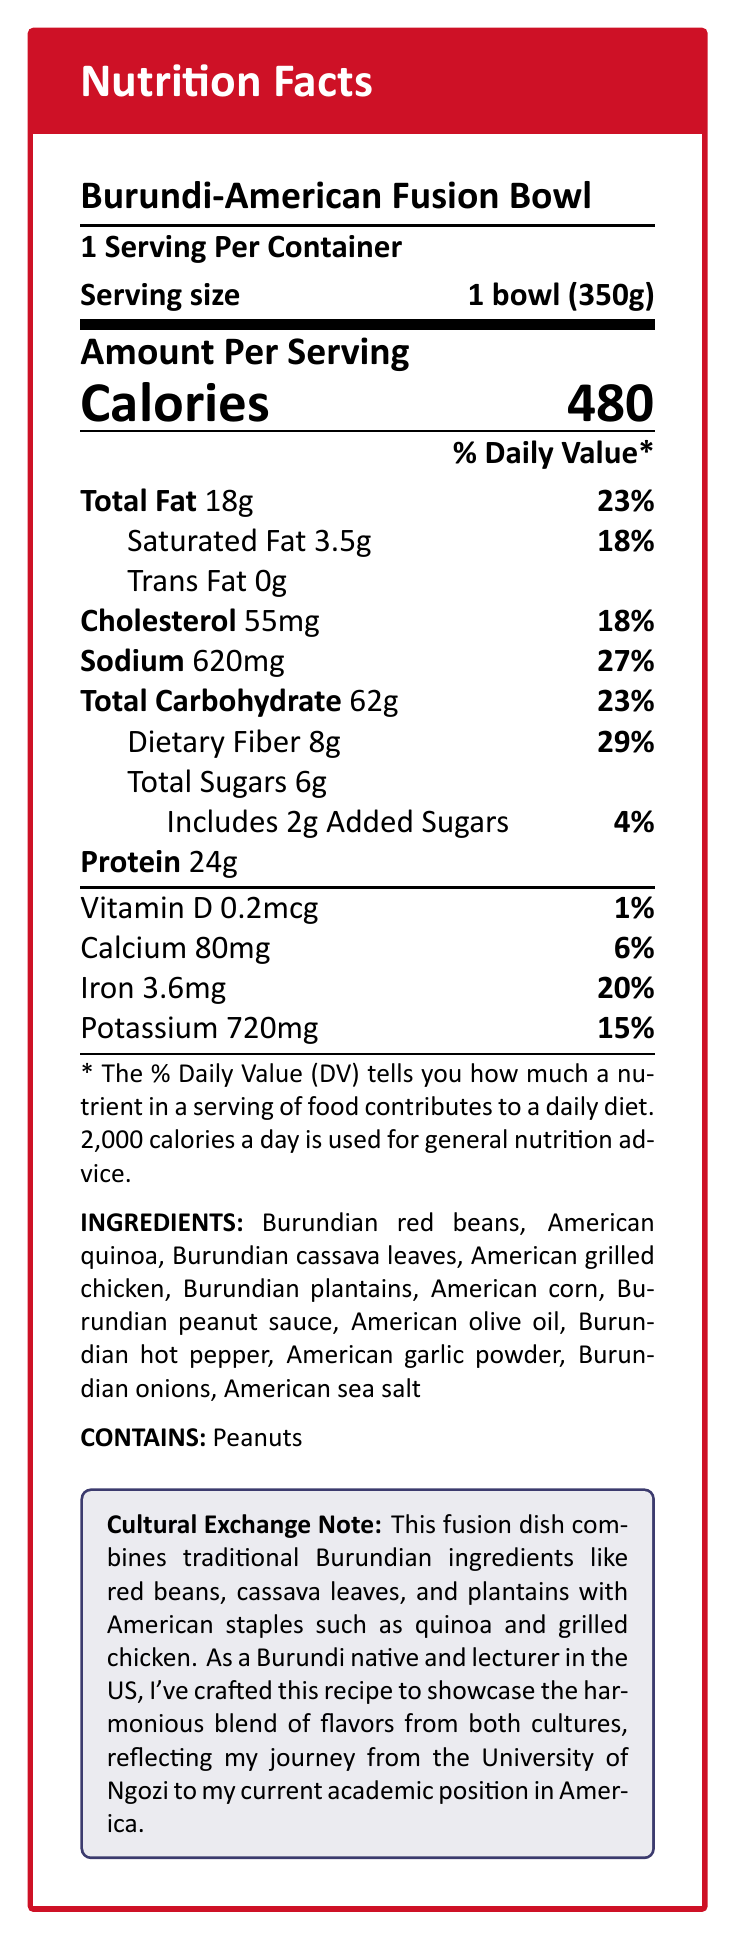what is the serving size of the Burundi-American Fusion Bowl? The serving size is directly stated in the document.
Answer: 1 bowl (350g) how many calories are in one serving of the fusion dish? The calories per serving are listed as 480 in the document.
Answer: 480 what is the total amount of fat in the fusion bowl? The document specifies that the total amount of fat is 18g.
Answer: 18g what percentage of the daily value of dietary fiber does one serving provide? The document indicates that one serving provides 29% of the daily value of dietary fiber.
Answer: 29% how much protein is in one serving of the fusion dish? The document states that there are 24g of protein in one serving.
Answer: 24g what type of fat is absent from the fusion bowl? A. Saturated Fat B. Trans Fat C. Total Fat D. Monounsaturated Fat The document mentions that Trans Fat is 0g, indicating its absence.
Answer: B what is the amount of iron in the fusion bowl, and what percentage of the daily value does it represent? The document states the bowl contains 3.6mg of iron, which is 20% of the daily value.
Answer: 3.6mg, 20% does the fusion bowl contain peanuts? The document explicitly lists peanuts as part of the allergens.
Answer: Yes which ingredient in the fusion bowl reflects my Burundian heritage? A. Quinoa B. Grilled Chicken C. Cassava Leaves D. Olive Oil The document lists Burundian cassava leaves as one of the ingredients.
Answer: C is there any added sugar in the fusion bowl? The document states that the dish includes 2g of added sugars.
Answer: Yes summarize the main idea of the document. The document outlines the nutritional content, ingredients, allergens, and cultural significance of the fusion dish, emphasizing how it marries Burundian and American food elements.
Answer: The document provides a detailed nutritional breakdown of the Burundi-American Fusion Bowl, highlighting the harmonious blend of flavors and ingredients from both Burundian and American culinary traditions. As a Burundi native and academic in the US, the creator crafted this dish to reflect their cultural and professional journey. how much vitamin D is in one serving? The document specifies that there is 0.2mcg of vitamin D in one serving.
Answer: 0.2mcg what is the total carbohydrate content, and what percentage of the daily value does it represent? The document states the total carbohydrate content is 62g, which equals 23% of the daily value.
Answer: 62g, 23% can you determine the exact recipe or preparation steps for this fusion bowl from the document? The document provides ingredient information and nutritional facts but does not include the recipe or preparation steps.
Answer: Cannot be determined which ingredient is not listed as part of the fusion bowl? A. Burundian red beans B. American quinoa C. Burundian fish D. Burundian peanut sauce The document does not list Burundian fish among the ingredients.
Answer: C is the bowl low, moderate, or high in sodium based on the daily value percentage? A. Low B. Moderate C. High The bowl contains 620mg of sodium, which is 27% of the daily value, and is typically considered high in sodium.
Answer: C 